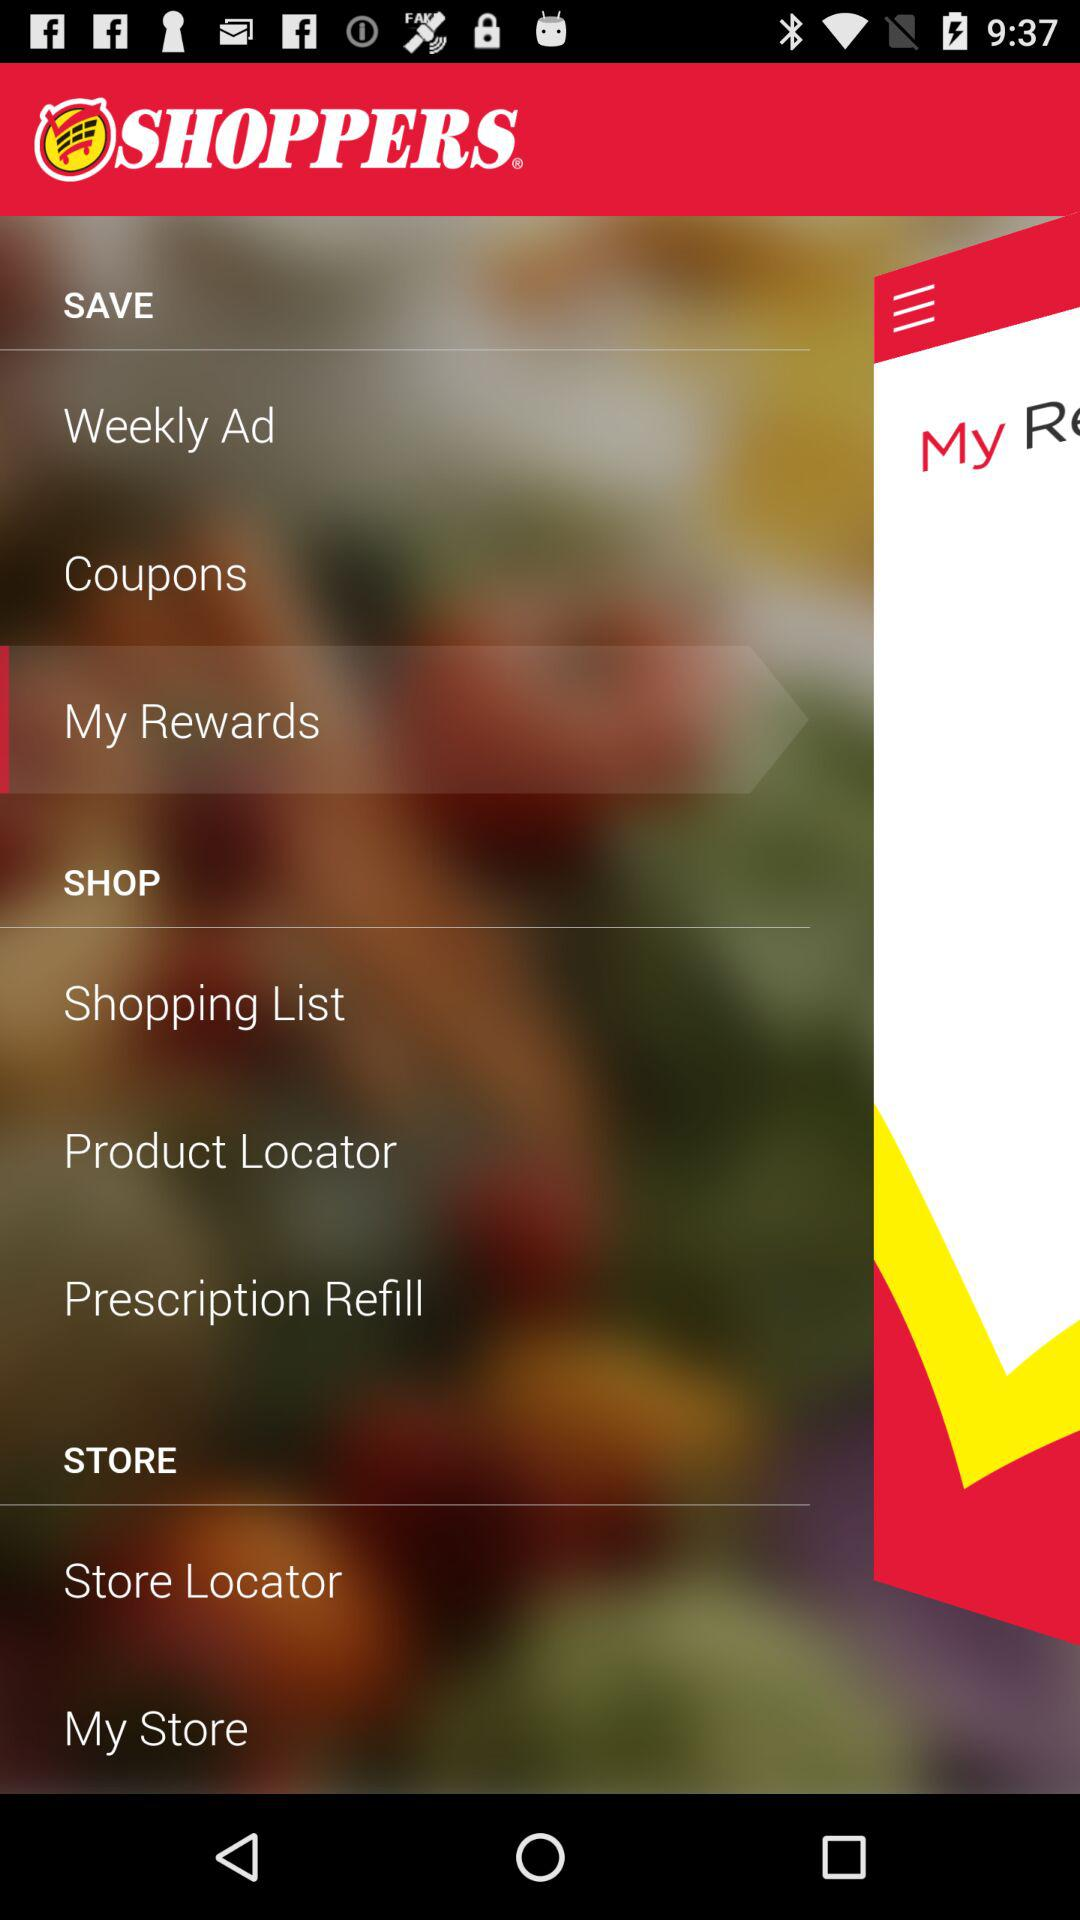What is the name of the application? The name of the application is "SHOPPERS". 